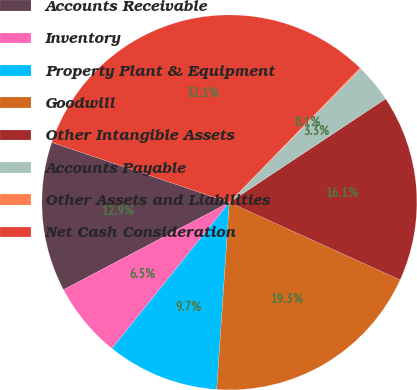Convert chart to OTSL. <chart><loc_0><loc_0><loc_500><loc_500><pie_chart><fcel>Accounts Receivable<fcel>Inventory<fcel>Property Plant & Equipment<fcel>Goodwill<fcel>Other Intangible Assets<fcel>Accounts Payable<fcel>Other Assets and Liabilities<fcel>Net Cash Consideration<nl><fcel>12.9%<fcel>6.51%<fcel>9.7%<fcel>19.29%<fcel>16.1%<fcel>3.31%<fcel>0.11%<fcel>32.08%<nl></chart> 